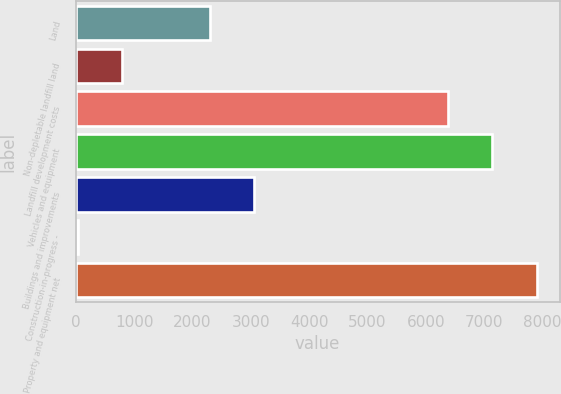Convert chart to OTSL. <chart><loc_0><loc_0><loc_500><loc_500><bar_chart><fcel>Land<fcel>Non-depletable landfill land<fcel>Landfill development costs<fcel>Vehicles and equipment<fcel>Buildings and improvements<fcel>Construction-in-progress -<fcel>Property and equipment net<nl><fcel>2301.57<fcel>790.99<fcel>6386.7<fcel>7141.99<fcel>3056.86<fcel>35.7<fcel>7897.28<nl></chart> 